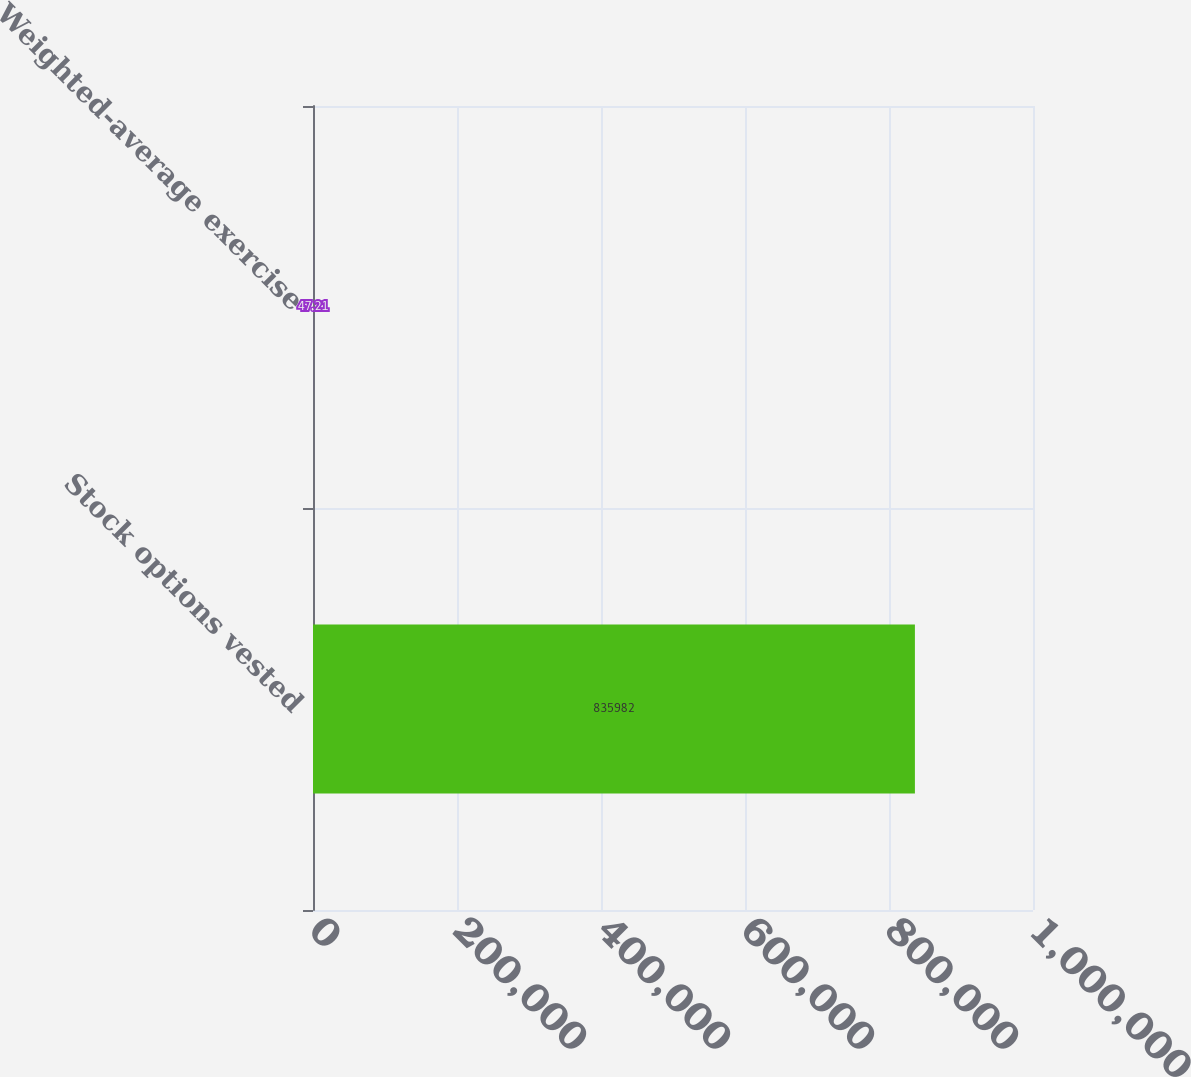<chart> <loc_0><loc_0><loc_500><loc_500><bar_chart><fcel>Stock options vested<fcel>Weighted-average exercise<nl><fcel>835982<fcel>47.21<nl></chart> 